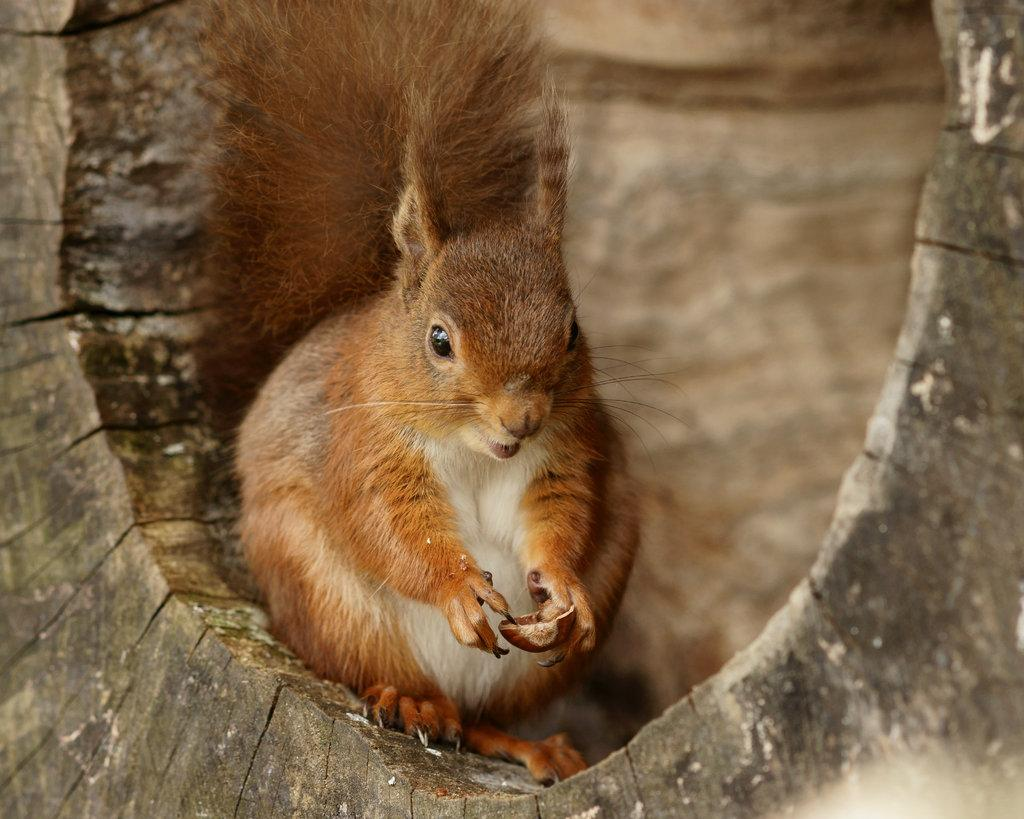What animal is present in the image? There is a squirrel in the image. Where is the squirrel located? The squirrel is on the trunk of a tree. What is the squirrel holding? The squirrel is holding a nut. What type of notebook can be seen in the image? There is no notebook present in the image; it features a squirrel on a tree trunk holding a nut. 